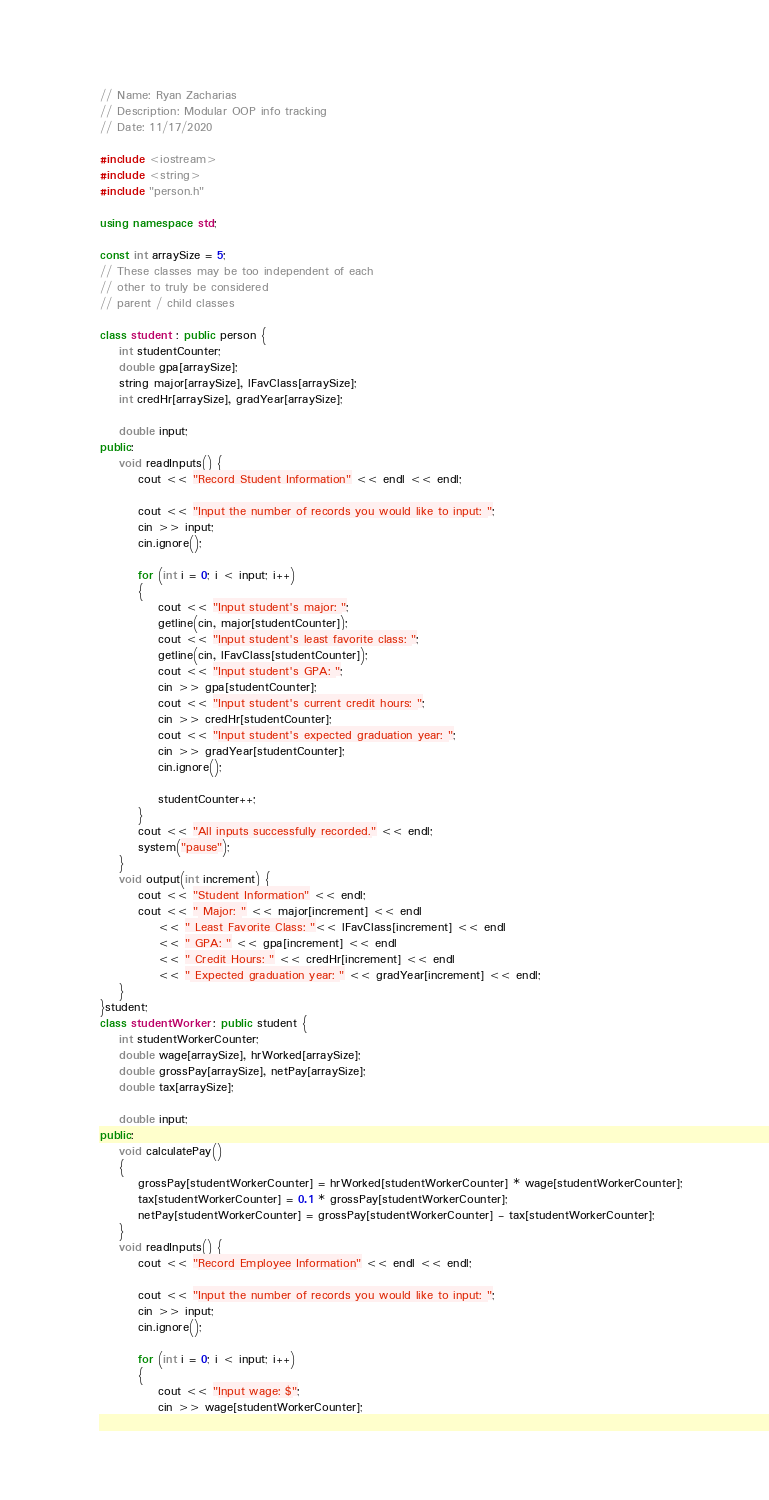<code> <loc_0><loc_0><loc_500><loc_500><_C++_>// Name: Ryan Zacharias
// Description: Modular OOP info tracking
// Date: 11/17/2020

#include <iostream>
#include <string>
#include "person.h"

using namespace std;

const int arraySize = 5;
// These classes may be too independent of each
// other to truly be considered 
// parent / child classes

class student : public person {
	int studentCounter;
	double gpa[arraySize];
	string major[arraySize], lFavClass[arraySize];
	int credHr[arraySize], gradYear[arraySize];

	double input;
public:
	void readInputs() {
		cout << "Record Student Information" << endl << endl;

		cout << "Input the number of records you would like to input: ";
		cin >> input;
		cin.ignore();

		for (int i = 0; i < input; i++)
		{
			cout << "Input student's major: ";
			getline(cin, major[studentCounter]);
			cout << "Input student's least favorite class: ";
			getline(cin, lFavClass[studentCounter]);
			cout << "Input student's GPA: ";
			cin >> gpa[studentCounter];
			cout << "Input student's current credit hours: ";
			cin >> credHr[studentCounter];
			cout << "Input student's expected graduation year: ";
			cin >> gradYear[studentCounter];
			cin.ignore();

			studentCounter++;
		}
		cout << "All inputs successfully recorded." << endl;
		system("pause");
	}
	void output(int increment) {
		cout << "Student Information" << endl;
		cout << " Major: " << major[increment] << endl
			<< " Least Favorite Class: "<< lFavClass[increment] << endl
			<< " GPA: " << gpa[increment] << endl
			<< " Credit Hours: " << credHr[increment] << endl
			<< " Expected graduation year: " << gradYear[increment] << endl;
	}
}student;
class studentWorker : public student {
	int studentWorkerCounter;
	double wage[arraySize], hrWorked[arraySize];
	double grossPay[arraySize], netPay[arraySize];
	double tax[arraySize];

	double input;
public:
	void calculatePay() 
	{
		grossPay[studentWorkerCounter] = hrWorked[studentWorkerCounter] * wage[studentWorkerCounter];
		tax[studentWorkerCounter] = 0.1 * grossPay[studentWorkerCounter];
		netPay[studentWorkerCounter] = grossPay[studentWorkerCounter] - tax[studentWorkerCounter];
	}
	void readInputs() {
		cout << "Record Employee Information" << endl << endl;

		cout << "Input the number of records you would like to input: ";
		cin >> input;
		cin.ignore();

		for (int i = 0; i < input; i++)
		{
			cout << "Input wage: $";
			cin >> wage[studentWorkerCounter];</code> 